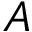<formula> <loc_0><loc_0><loc_500><loc_500>A</formula> 